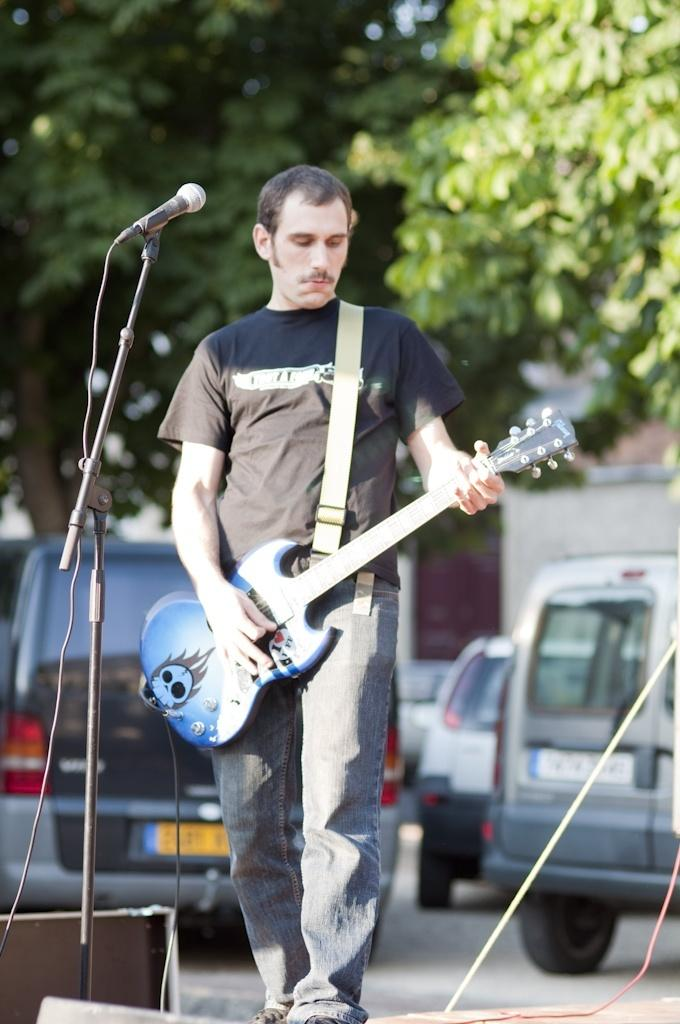What is the man in the image doing? The man is playing guitar. What is the object next to the man? There is a microphone with a stand. What can be seen in the background of the image? There are vehicles and trees in the background. What type of polish is being applied to the guitar in the image? There is no indication in the image that any polish is being applied to the guitar. 